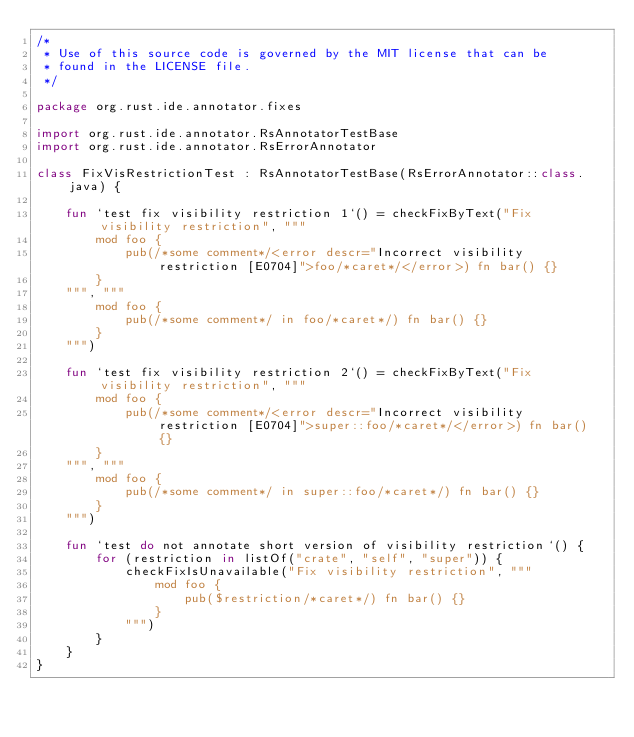Convert code to text. <code><loc_0><loc_0><loc_500><loc_500><_Kotlin_>/*
 * Use of this source code is governed by the MIT license that can be
 * found in the LICENSE file.
 */

package org.rust.ide.annotator.fixes

import org.rust.ide.annotator.RsAnnotatorTestBase
import org.rust.ide.annotator.RsErrorAnnotator

class FixVisRestrictionTest : RsAnnotatorTestBase(RsErrorAnnotator::class.java) {

    fun `test fix visibility restriction 1`() = checkFixByText("Fix visibility restriction", """
        mod foo {
            pub(/*some comment*/<error descr="Incorrect visibility restriction [E0704]">foo/*caret*/</error>) fn bar() {}
        }
    """, """
        mod foo {
            pub(/*some comment*/ in foo/*caret*/) fn bar() {}
        }
    """)

    fun `test fix visibility restriction 2`() = checkFixByText("Fix visibility restriction", """
        mod foo {
            pub(/*some comment*/<error descr="Incorrect visibility restriction [E0704]">super::foo/*caret*/</error>) fn bar() {}
        }
    """, """
        mod foo {
            pub(/*some comment*/ in super::foo/*caret*/) fn bar() {}
        }
    """)

    fun `test do not annotate short version of visibility restriction`() {
        for (restriction in listOf("crate", "self", "super")) {
            checkFixIsUnavailable("Fix visibility restriction", """
                mod foo {
                    pub($restriction/*caret*/) fn bar() {}
                }
            """)
        }
    }
}
</code> 